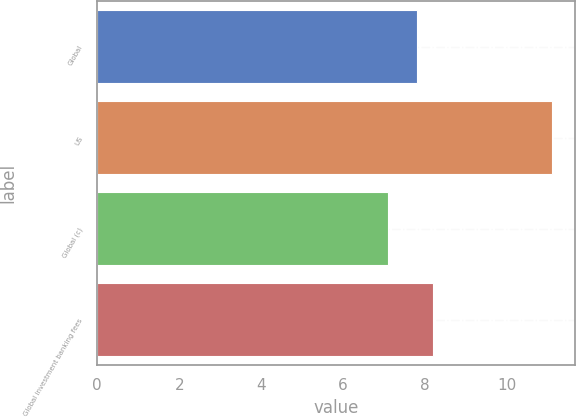<chart> <loc_0><loc_0><loc_500><loc_500><bar_chart><fcel>Global<fcel>US<fcel>Global (c)<fcel>Global investment banking fees<nl><fcel>7.8<fcel>11.1<fcel>7.1<fcel>8.2<nl></chart> 